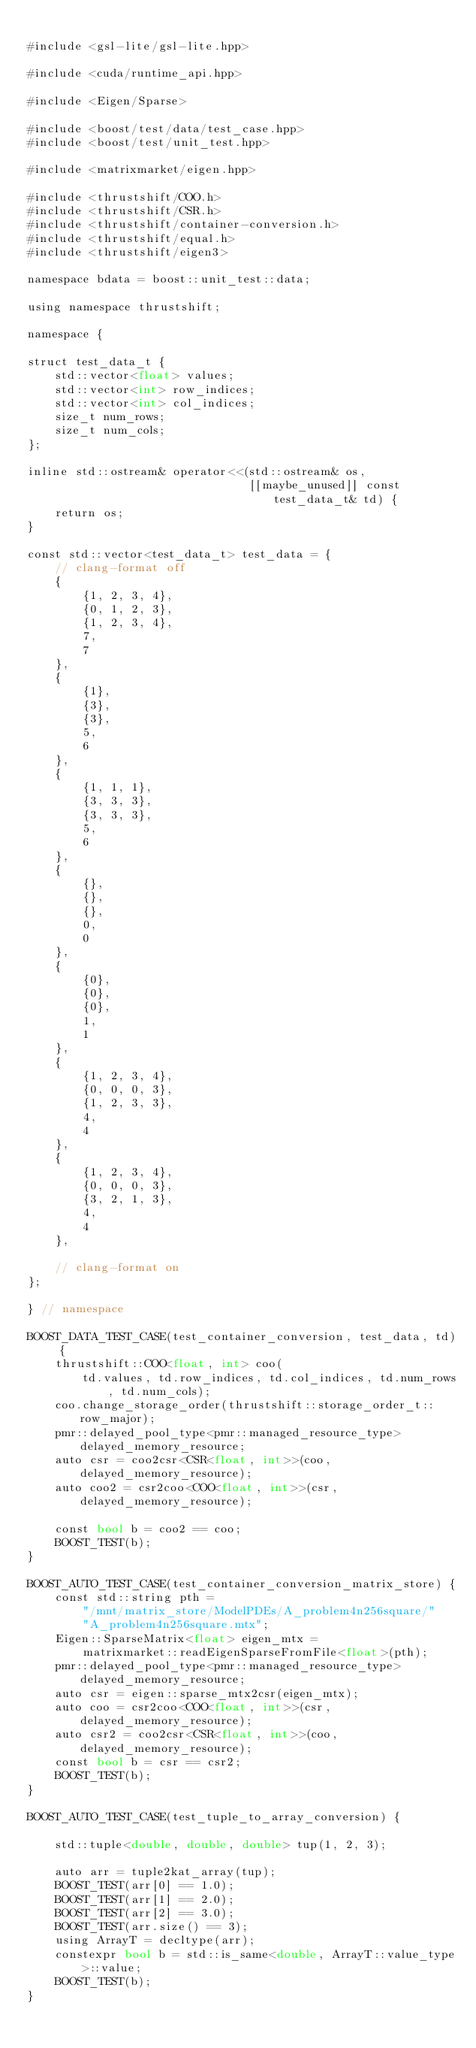Convert code to text. <code><loc_0><loc_0><loc_500><loc_500><_Cuda_>
#include <gsl-lite/gsl-lite.hpp>

#include <cuda/runtime_api.hpp>

#include <Eigen/Sparse>

#include <boost/test/data/test_case.hpp>
#include <boost/test/unit_test.hpp>

#include <matrixmarket/eigen.hpp>

#include <thrustshift/COO.h>
#include <thrustshift/CSR.h>
#include <thrustshift/container-conversion.h>
#include <thrustshift/equal.h>
#include <thrustshift/eigen3>

namespace bdata = boost::unit_test::data;

using namespace thrustshift;

namespace {

struct test_data_t {
	std::vector<float> values;
	std::vector<int> row_indices;
	std::vector<int> col_indices;
	size_t num_rows;
	size_t num_cols;
};

inline std::ostream& operator<<(std::ostream& os,
                                [[maybe_unused]] const test_data_t& td) {
	return os;
}

const std::vector<test_data_t> test_data = {
    // clang-format off
	{
		{1, 2, 3, 4},
		{0, 1, 2, 3},
		{1, 2, 3, 4},
		7,
		7
	},
	{
		{1},
		{3},
		{3},
		5,
		6
	},
	{
		{1, 1, 1},
		{3, 3, 3},
		{3, 3, 3},
		5,
		6
	},
	{
		{},
		{},
		{},
		0,
		0
	},
	{
		{0},
		{0},
		{0},
		1,
		1
	},
	{
		{1, 2, 3, 4},
		{0, 0, 0, 3},
		{1, 2, 3, 3},
		4,
		4
	},
	{
		{1, 2, 3, 4},
		{0, 0, 0, 3},
		{3, 2, 1, 3},
		4,
		4
	},

    // clang-format on
};

} // namespace

BOOST_DATA_TEST_CASE(test_container_conversion, test_data, td) {
	thrustshift::COO<float, int> coo(
	    td.values, td.row_indices, td.col_indices, td.num_rows, td.num_cols);
	coo.change_storage_order(thrustshift::storage_order_t::row_major);
	pmr::delayed_pool_type<pmr::managed_resource_type> delayed_memory_resource;
	auto csr = coo2csr<CSR<float, int>>(coo, delayed_memory_resource);
	auto coo2 = csr2coo<COO<float, int>>(csr, delayed_memory_resource);

	const bool b = coo2 == coo;
	BOOST_TEST(b);
}

BOOST_AUTO_TEST_CASE(test_container_conversion_matrix_store) {
	const std::string pth =
	    "/mnt/matrix_store/ModelPDEs/A_problem4n256square/"
	    "A_problem4n256square.mtx";
	Eigen::SparseMatrix<float> eigen_mtx =
	    matrixmarket::readEigenSparseFromFile<float>(pth);
	pmr::delayed_pool_type<pmr::managed_resource_type> delayed_memory_resource;
	auto csr = eigen::sparse_mtx2csr(eigen_mtx);
	auto coo = csr2coo<COO<float, int>>(csr, delayed_memory_resource);
	auto csr2 = coo2csr<CSR<float, int>>(coo, delayed_memory_resource);
	const bool b = csr == csr2;
	BOOST_TEST(b);
}

BOOST_AUTO_TEST_CASE(test_tuple_to_array_conversion) {

	std::tuple<double, double, double> tup(1, 2, 3);

	auto arr = tuple2kat_array(tup);
	BOOST_TEST(arr[0] == 1.0);
	BOOST_TEST(arr[1] == 2.0);
	BOOST_TEST(arr[2] == 3.0);
	BOOST_TEST(arr.size() == 3);
	using ArrayT = decltype(arr);
	constexpr bool b = std::is_same<double, ArrayT::value_type>::value;
	BOOST_TEST(b);
}
</code> 